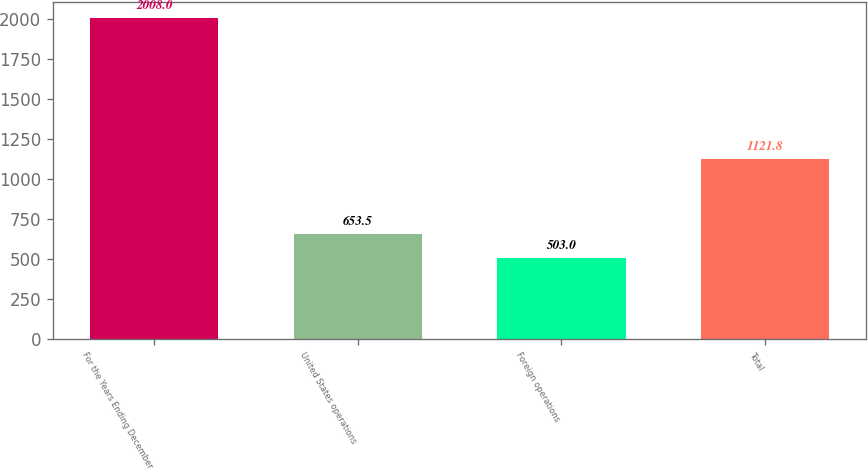Convert chart to OTSL. <chart><loc_0><loc_0><loc_500><loc_500><bar_chart><fcel>For the Years Ending December<fcel>United States operations<fcel>Foreign operations<fcel>Total<nl><fcel>2008<fcel>653.5<fcel>503<fcel>1121.8<nl></chart> 